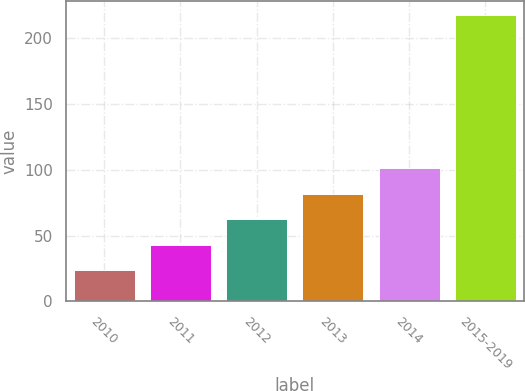Convert chart to OTSL. <chart><loc_0><loc_0><loc_500><loc_500><bar_chart><fcel>2010<fcel>2011<fcel>2012<fcel>2013<fcel>2014<fcel>2015-2019<nl><fcel>23.7<fcel>43.1<fcel>62.5<fcel>81.9<fcel>101.3<fcel>217.7<nl></chart> 